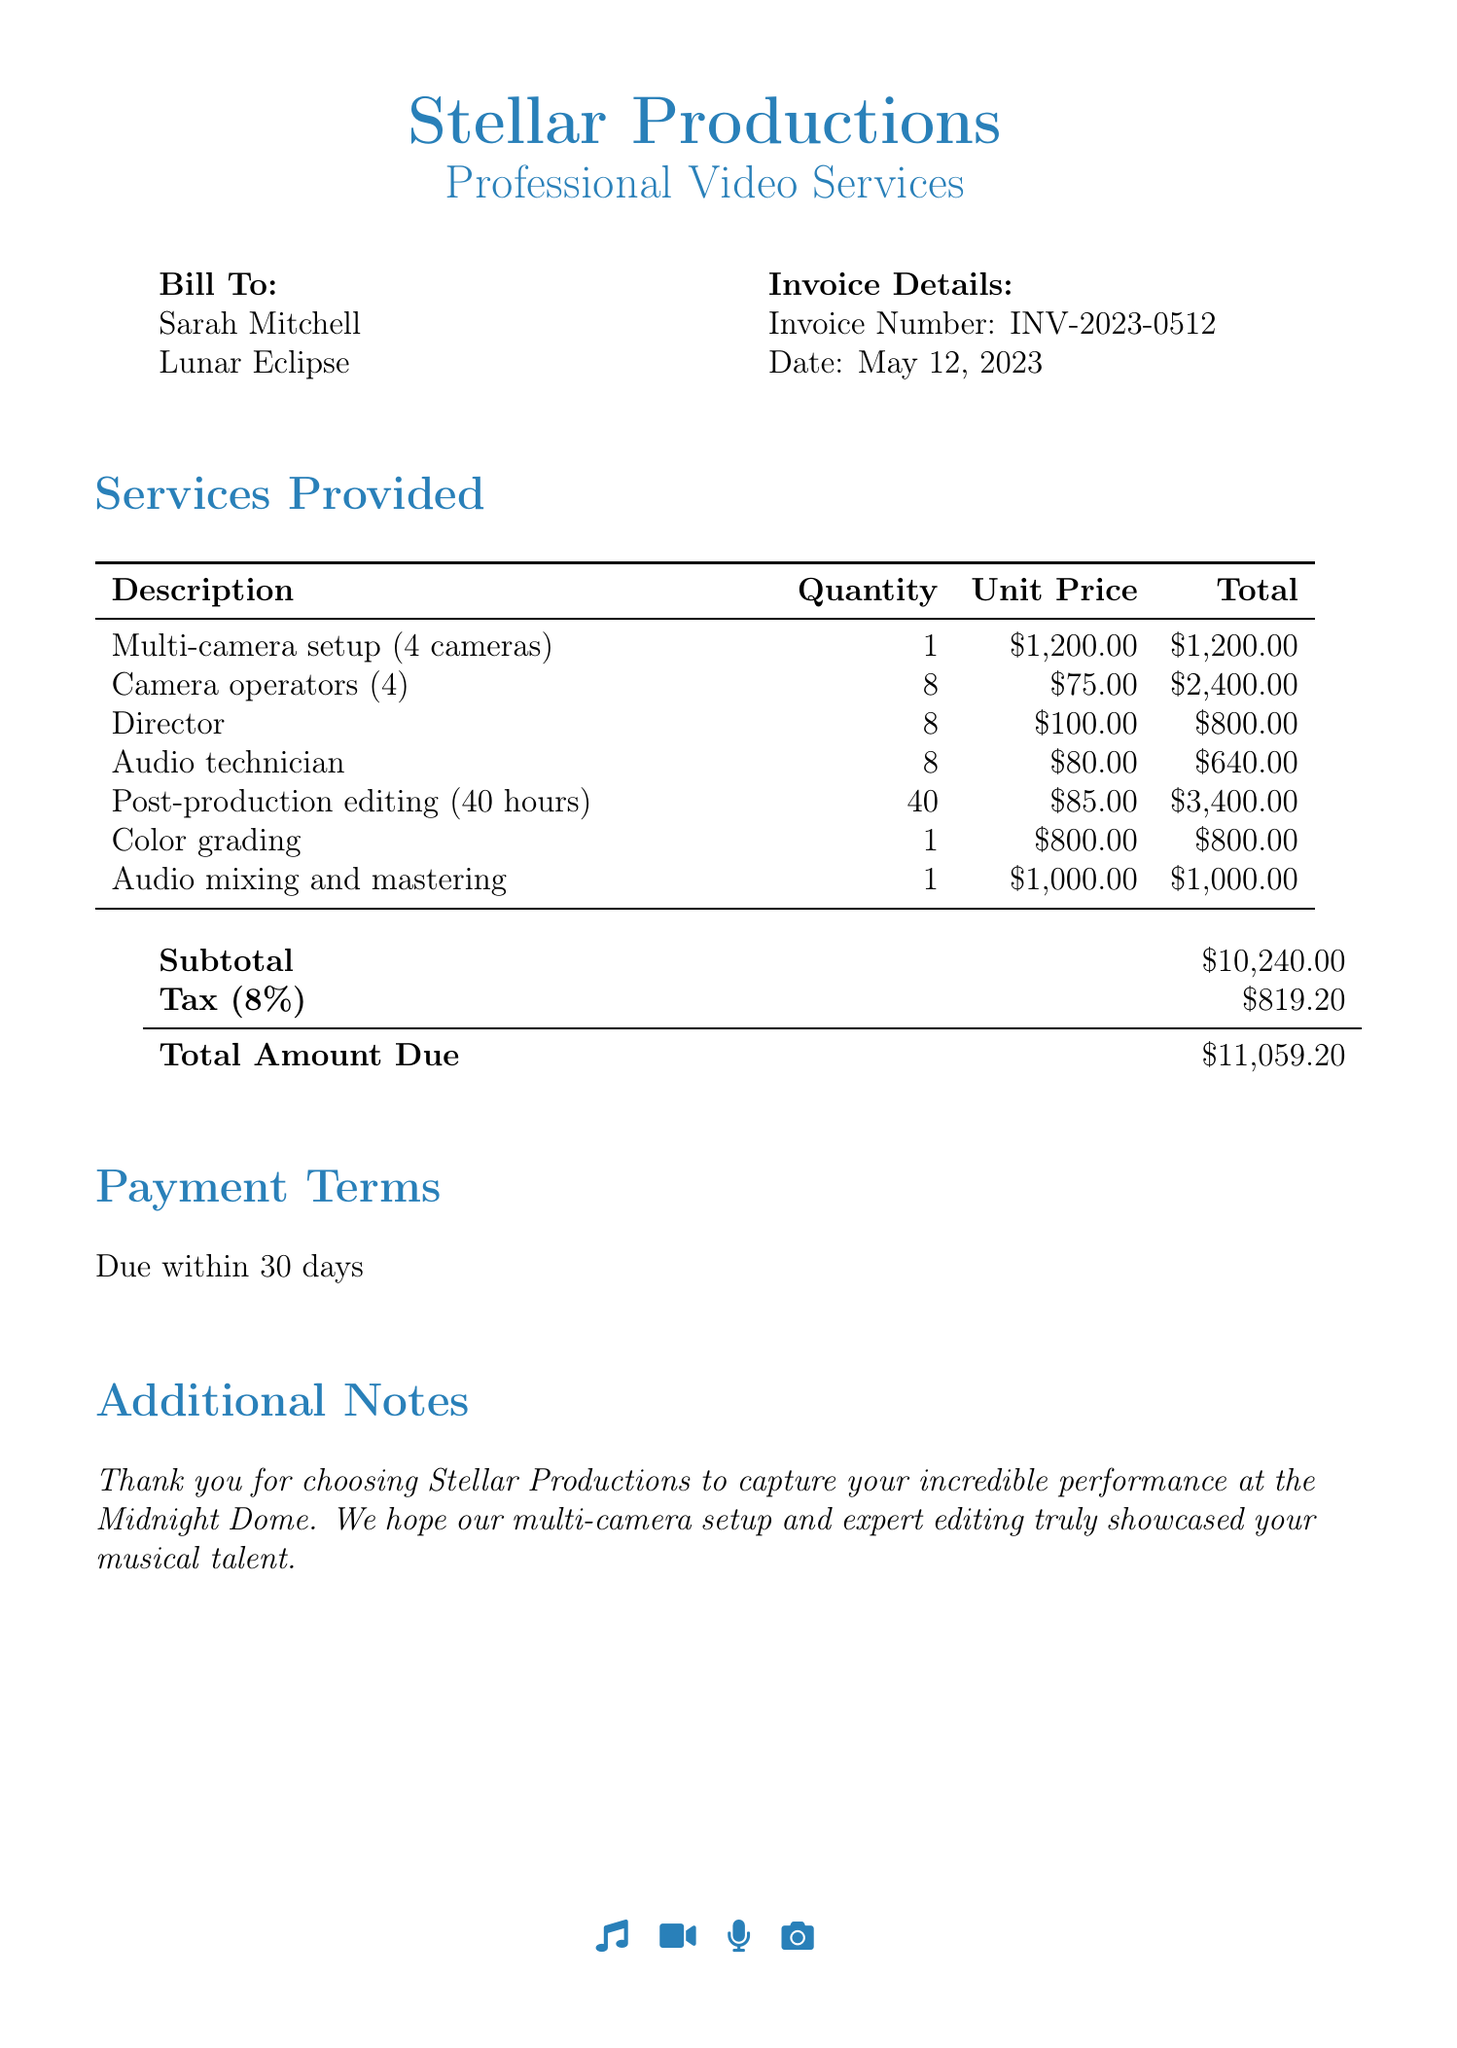What is the invoice number? The invoice number is listed in the invoice details section.
Answer: INV-2023-0512 What is the date of the invoice? The date of the invoice is specified in the invoice details section.
Answer: May 12, 2023 How many cameras were used in the multi-camera setup? The number of cameras is detailed in the services provided section under multi-camera setup.
Answer: 4 cameras What is the total amount due? The total amount due is provided in the payment summary section of the invoice.
Answer: $11,059.20 How many hours of post-production editing were performed? The number of hours is stated in the description of post-production editing in the services provided section.
Answer: 40 hours What is the unit price of the audio technician? The unit price for the audio technician service can be found in the services provided table.
Answer: $80.00 What percentage is the tax applied to the subtotal? The tax percentage is mentioned in the payment summary section of the invoice.
Answer: 8% What is the subtotal before tax? The subtotal is provided in the payment summary section prior to adding tax.
Answer: $10,240.00 Who is the bill to? The recipient of the bill is indicated at the beginning of the document under 'Bill To.'
Answer: Sarah Mitchell 